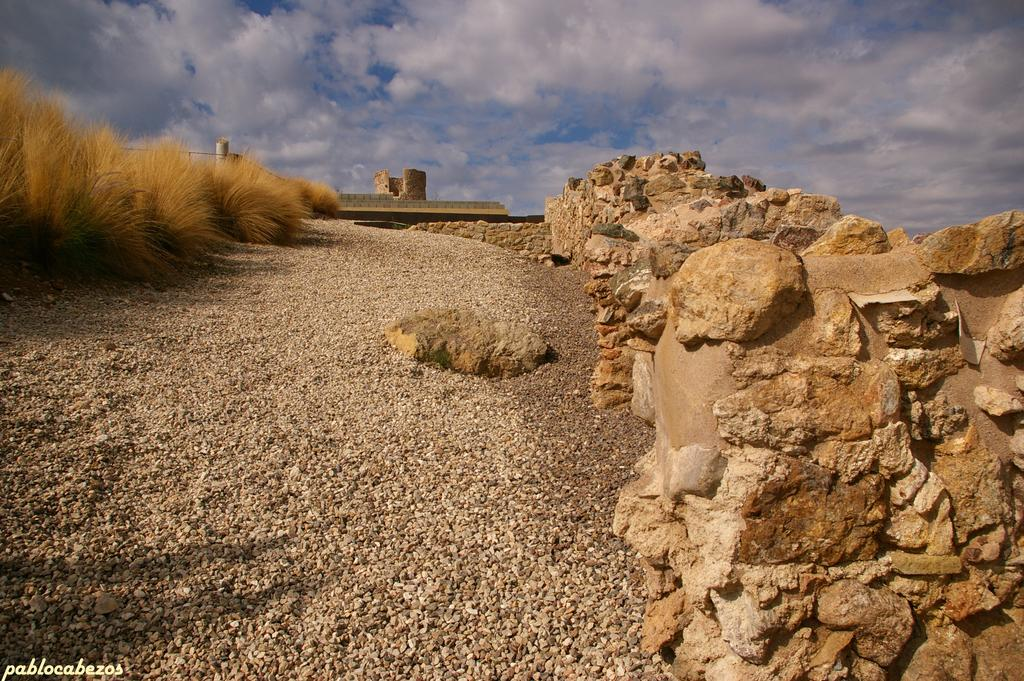What is the main feature of the image? There is a road in the image. What can be seen on the right side of the road? There are rocks on the right side of the image. What is present on the left side of the road? There are dried plants on the left side of the image. What is visible in the sky at the top of the image? There are clouds in the sky at the top of the image. What type of development is taking place on the road in the image? There is no development taking place on the road in the image; it is simply a road with rocks and dried plants on either side. Can you see a tank driving along the road in the image? There is no tank present in the image. 